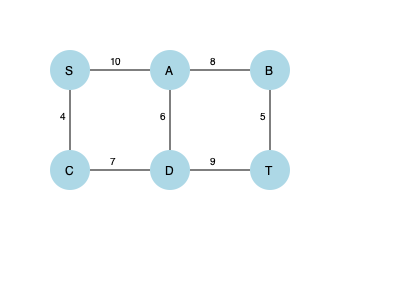Dado el grafo de flujo de red mostrado, donde S es la fuente y T es el sumidero, ¿cuál es el flujo máximo de S a T utilizando el algoritmo de Ford-Fulkerson? Además, identifique el corte mínimo en el grafo. Para resolver este problema, aplicaremos el algoritmo de Ford-Fulkerson paso a paso:

1) Inicializamos el flujo en todas las aristas a 0.

2) Buscamos un camino de aumento de S a T:
   S → A → B → T (flujo = min(10, 8, 5) = 5)
   Actualizamos el flujo: 5 unidades a lo largo de este camino.

3) Buscamos otro camino de aumento:
   S → C → D → T (flujo = min(4, 7, 9) = 4)
   Actualizamos el flujo: 4 unidades a lo largo de este camino.

4) Buscamos otro camino de aumento:
   S → A → D → T (flujo = min(5, 6, 5) = 5)
   Actualizamos el flujo: 5 unidades a lo largo de este camino.

5) No hay más caminos de aumento posibles.

El flujo máximo es la suma de todos los flujos: 5 + 4 + 5 = 14.

Para encontrar el corte mínimo, identificamos el conjunto de nodos alcanzables desde S en el grafo residual:
- Nodos alcanzables: {S, A, C}
- Nodos no alcanzables: {B, D, T}

El corte mínimo está formado por las aristas que conectan estos dos conjuntos:
- A → B (capacidad 8)
- A → D (capacidad 6)
- C → D (capacidad 7)

La suma de las capacidades de estas aristas es 8 + 6 + 7 = 21, que es igual a la capacidad del corte mínimo.
Answer: Flujo máximo: 14. Corte mínimo: {(A,B), (A,D), (C,D)}. 